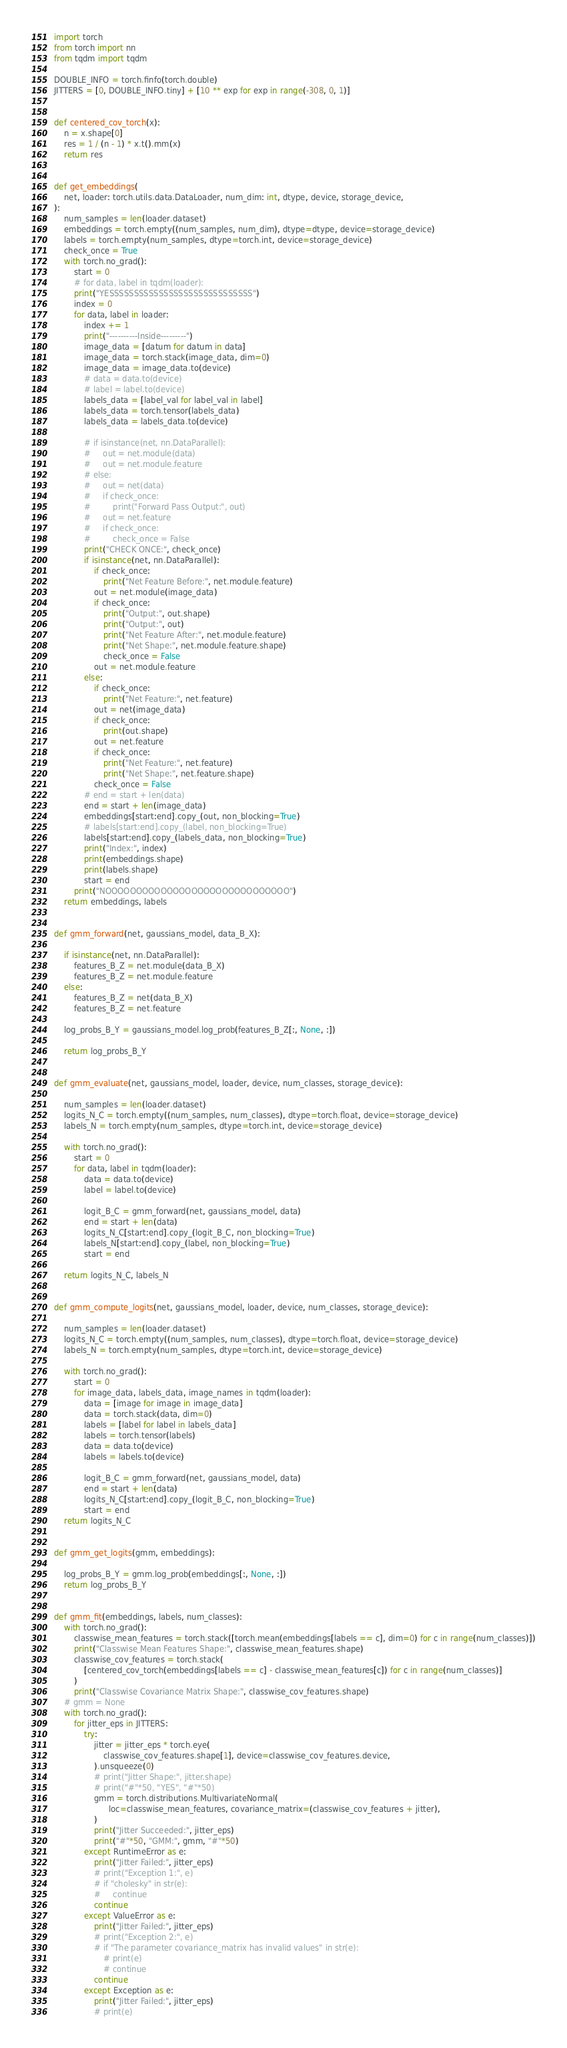<code> <loc_0><loc_0><loc_500><loc_500><_Python_>import torch
from torch import nn
from tqdm import tqdm

DOUBLE_INFO = torch.finfo(torch.double)
JITTERS = [0, DOUBLE_INFO.tiny] + [10 ** exp for exp in range(-308, 0, 1)]


def centered_cov_torch(x):
    n = x.shape[0]
    res = 1 / (n - 1) * x.t().mm(x)
    return res


def get_embeddings(
    net, loader: torch.utils.data.DataLoader, num_dim: int, dtype, device, storage_device,
):
    num_samples = len(loader.dataset)
    embeddings = torch.empty((num_samples, num_dim), dtype=dtype, device=storage_device)
    labels = torch.empty(num_samples, dtype=torch.int, device=storage_device)
    check_once = True
    with torch.no_grad():
        start = 0
        # for data, label in tqdm(loader):
        print("YESSSSSSSSSSSSSSSSSSSSSSSSSSSSS")
        index = 0
        for data, label in loader:
            index += 1
            print("----------Inside---------")
            image_data = [datum for datum in data]
            image_data = torch.stack(image_data, dim=0)
            image_data = image_data.to(device)
            # data = data.to(device)
            # label = label.to(device)
            labels_data = [label_val for label_val in label]
            labels_data = torch.tensor(labels_data)
            labels_data = labels_data.to(device)

            # if isinstance(net, nn.DataParallel):
            #     out = net.module(data)
            #     out = net.module.feature
            # else:
            #     out = net(data)
            #     if check_once:
            #         print("Forward Pass Output:", out)
            #     out = net.feature
            #     if check_once:
            #         check_once = False
            print("CHECK ONCE:", check_once)
            if isinstance(net, nn.DataParallel):
                if check_once:
                    print("Net Feature Before:", net.module.feature)
                out = net.module(image_data)
                if check_once:
                    print("Output:", out.shape)
                    print("Output:", out)
                    print("Net Feature After:", net.module.feature)
                    print("Net Shape:", net.module.feature.shape)
                    check_once = False
                out = net.module.feature
            else:
                if check_once:
                    print("Net Feature:", net.feature)
                out = net(image_data)
                if check_once:
                    print(out.shape)
                out = net.feature
                if check_once:
                    print("Net Feature:", net.feature)
                    print("Net Shape:", net.feature.shape)
                check_once = False
            # end = start + len(data)
            end = start + len(image_data)
            embeddings[start:end].copy_(out, non_blocking=True)
            # labels[start:end].copy_(label, non_blocking=True)
            labels[start:end].copy_(labels_data, non_blocking=True)
            print("Index:", index)
            print(embeddings.shape)
            print(labels.shape)
            start = end
        print("NOOOOOOOOOOOOOOOOOOOOOOOOOOOOOO")
    return embeddings, labels


def gmm_forward(net, gaussians_model, data_B_X):

    if isinstance(net, nn.DataParallel):
        features_B_Z = net.module(data_B_X)
        features_B_Z = net.module.feature
    else:
        features_B_Z = net(data_B_X)
        features_B_Z = net.feature

    log_probs_B_Y = gaussians_model.log_prob(features_B_Z[:, None, :])

    return log_probs_B_Y


def gmm_evaluate(net, gaussians_model, loader, device, num_classes, storage_device):

    num_samples = len(loader.dataset)
    logits_N_C = torch.empty((num_samples, num_classes), dtype=torch.float, device=storage_device)
    labels_N = torch.empty(num_samples, dtype=torch.int, device=storage_device)

    with torch.no_grad():
        start = 0
        for data, label in tqdm(loader):
            data = data.to(device)
            label = label.to(device)

            logit_B_C = gmm_forward(net, gaussians_model, data)
            end = start + len(data)
            logits_N_C[start:end].copy_(logit_B_C, non_blocking=True)
            labels_N[start:end].copy_(label, non_blocking=True)
            start = end

    return logits_N_C, labels_N


def gmm_compute_logits(net, gaussians_model, loader, device, num_classes, storage_device):

    num_samples = len(loader.dataset)
    logits_N_C = torch.empty((num_samples, num_classes), dtype=torch.float, device=storage_device)
    labels_N = torch.empty(num_samples, dtype=torch.int, device=storage_device)

    with torch.no_grad():
        start = 0
        for image_data, labels_data, image_names in tqdm(loader):
            data = [image for image in image_data]
            data = torch.stack(data, dim=0)
            labels = [label for label in labels_data]
            labels = torch.tensor(labels)
            data = data.to(device)
            labels = labels.to(device)

            logit_B_C = gmm_forward(net, gaussians_model, data)
            end = start + len(data)
            logits_N_C[start:end].copy_(logit_B_C, non_blocking=True)
            start = end
    return logits_N_C


def gmm_get_logits(gmm, embeddings):

    log_probs_B_Y = gmm.log_prob(embeddings[:, None, :])
    return log_probs_B_Y


def gmm_fit(embeddings, labels, num_classes):
    with torch.no_grad():
        classwise_mean_features = torch.stack([torch.mean(embeddings[labels == c], dim=0) for c in range(num_classes)])
        print("Classwise Mean Features Shape:", classwise_mean_features.shape)
        classwise_cov_features = torch.stack(
            [centered_cov_torch(embeddings[labels == c] - classwise_mean_features[c]) for c in range(num_classes)]
        )
        print("Classwise Covariance Matrix Shape:", classwise_cov_features.shape)
    # gmm = None
    with torch.no_grad():
        for jitter_eps in JITTERS:
            try:
                jitter = jitter_eps * torch.eye(
                    classwise_cov_features.shape[1], device=classwise_cov_features.device,
                ).unsqueeze(0)
                # print("Jitter Shape:", jitter.shape)
                # print("#"*50, "YES", "#"*50)
                gmm = torch.distributions.MultivariateNormal(
                      loc=classwise_mean_features, covariance_matrix=(classwise_cov_features + jitter),
                )
                print("Jitter Succeeded:", jitter_eps)
                print("#"*50, "GMM:", gmm, "#"*50)
            except RuntimeError as e:
                print("Jitter Failed:", jitter_eps)
                # print("Exception 1:", e)
                # if "cholesky" in str(e):
                #     continue
                continue
            except ValueError as e:
                print("Jitter Failed:", jitter_eps)
                # print("Exception 2:", e)
                # if "The parameter covariance_matrix has invalid values" in str(e):
                    # print(e)
                    # continue
                continue
            except Exception as e:
                print("Jitter Failed:", jitter_eps)
                # print(e)</code> 